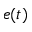Convert formula to latex. <formula><loc_0><loc_0><loc_500><loc_500>e ( t )</formula> 